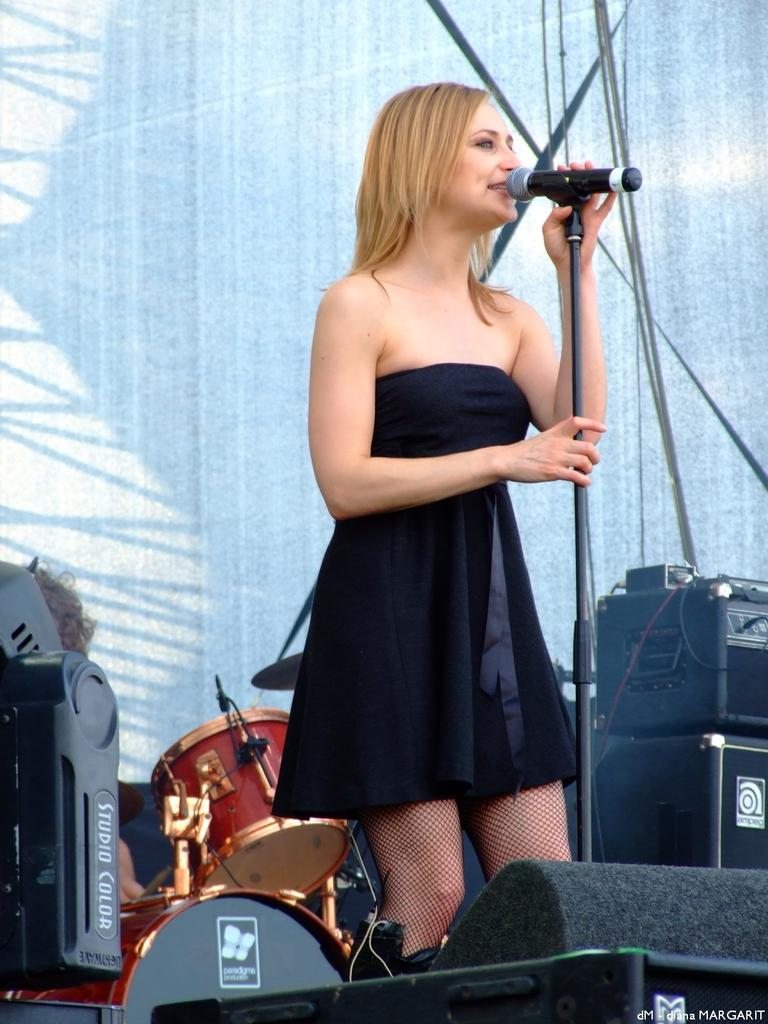What is the main subject of the image? There is a person in the image. What is the person wearing? The person is wearing a black dress. What is the person doing in the image? The person is speaking into a microphone. What can be seen in the background of the image? There are red drums and speakers in the background. How long does the discussion in the image last for? There is no discussion taking place in the image; the person is speaking into a microphone. 